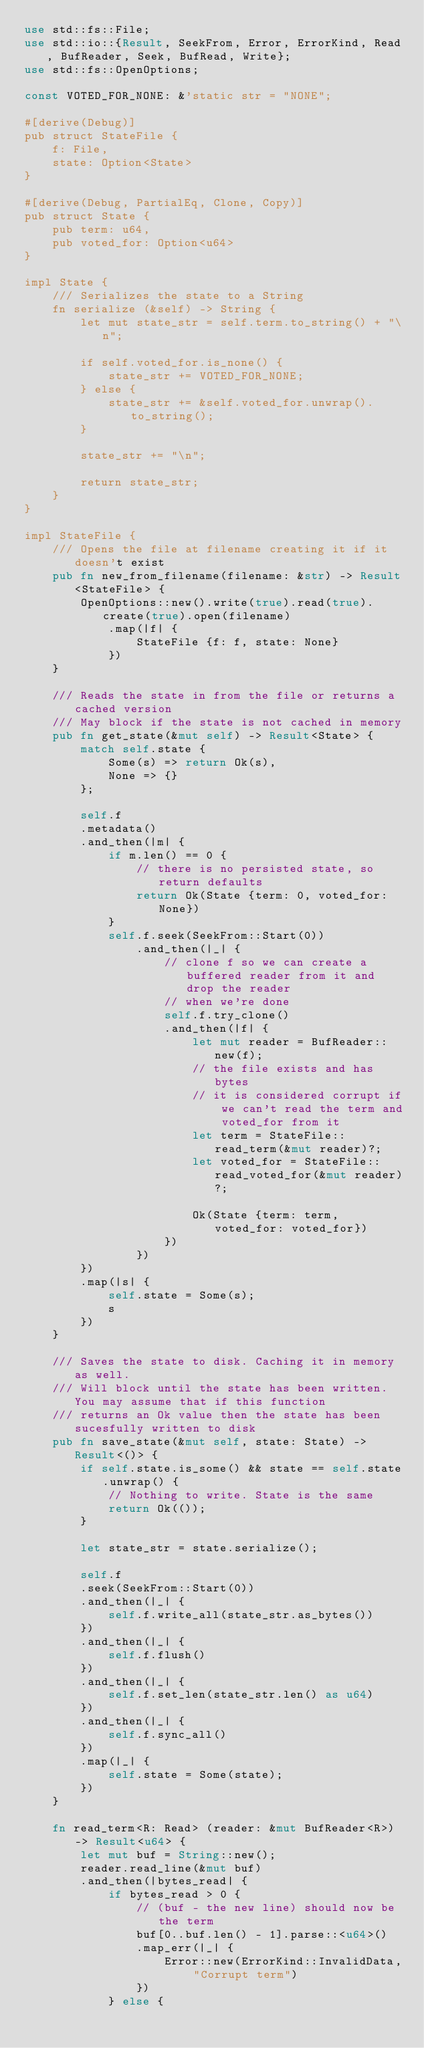Convert code to text. <code><loc_0><loc_0><loc_500><loc_500><_Rust_>use std::fs::File;
use std::io::{Result, SeekFrom, Error, ErrorKind, Read, BufReader, Seek, BufRead, Write};
use std::fs::OpenOptions;

const VOTED_FOR_NONE: &'static str = "NONE";

#[derive(Debug)]
pub struct StateFile {
    f: File,
    state: Option<State>
}

#[derive(Debug, PartialEq, Clone, Copy)]
pub struct State {
    pub term: u64,
    pub voted_for: Option<u64>
}

impl State {
    /// Serializes the state to a String
    fn serialize (&self) -> String {
        let mut state_str = self.term.to_string() + "\n";

        if self.voted_for.is_none() {
            state_str += VOTED_FOR_NONE;
        } else {
            state_str += &self.voted_for.unwrap().to_string();
        }
        
        state_str += "\n";

        return state_str;
    }
}

impl StateFile {
    /// Opens the file at filename creating it if it doesn't exist
    pub fn new_from_filename(filename: &str) -> Result<StateFile> {
        OpenOptions::new().write(true).read(true).create(true).open(filename)
            .map(|f| {
                StateFile {f: f, state: None}
            })
    }

    /// Reads the state in from the file or returns a cached version
    /// May block if the state is not cached in memory
    pub fn get_state(&mut self) -> Result<State> {
        match self.state {
            Some(s) => return Ok(s),
            None => {}
        };

        self.f
        .metadata()
        .and_then(|m| {
            if m.len() == 0 {
                // there is no persisted state, so return defaults
                return Ok(State {term: 0, voted_for: None})
            }
            self.f.seek(SeekFrom::Start(0))
                .and_then(|_| {
                    // clone f so we can create a buffered reader from it and drop the reader
                    // when we're done
                    self.f.try_clone()
                    .and_then(|f| {
                        let mut reader = BufReader::new(f);
                        // the file exists and has bytes
                        // it is considered corrupt if we can't read the term and voted_for from it
                        let term = StateFile::read_term(&mut reader)?;
                        let voted_for = StateFile::read_voted_for(&mut reader)?;

                        Ok(State {term: term, voted_for: voted_for})
                    })
                })
        })
        .map(|s| {
            self.state = Some(s);
            s
        })
    }

    /// Saves the state to disk. Caching it in memory as well.
    /// Will block until the state has been written. You may assume that if this function
    /// returns an Ok value then the state has been sucesfully written to disk
    pub fn save_state(&mut self, state: State) -> Result<()> {
        if self.state.is_some() && state == self.state.unwrap() {
            // Nothing to write. State is the same
            return Ok(());
        }

        let state_str = state.serialize();

        self.f
        .seek(SeekFrom::Start(0))
        .and_then(|_| {
            self.f.write_all(state_str.as_bytes())
        })
        .and_then(|_| {
            self.f.flush()
        })
        .and_then(|_| {
            self.f.set_len(state_str.len() as u64)
        })
        .and_then(|_| {
            self.f.sync_all()
        })
        .map(|_| {
            self.state = Some(state);
        })
    }

    fn read_term<R: Read> (reader: &mut BufReader<R>) -> Result<u64> {
        let mut buf = String::new();
        reader.read_line(&mut buf)
        .and_then(|bytes_read| {
            if bytes_read > 0 {
                // (buf - the new line) should now be the term
                buf[0..buf.len() - 1].parse::<u64>()
                .map_err(|_| {
                    Error::new(ErrorKind::InvalidData, "Corrupt term")
                })
            } else {</code> 